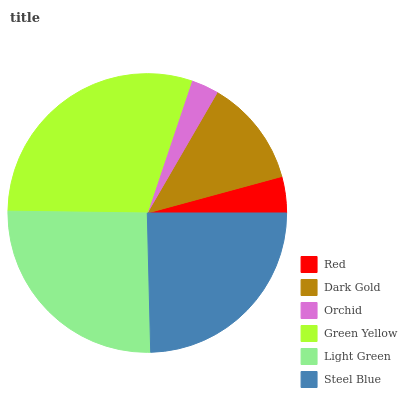Is Orchid the minimum?
Answer yes or no. Yes. Is Green Yellow the maximum?
Answer yes or no. Yes. Is Dark Gold the minimum?
Answer yes or no. No. Is Dark Gold the maximum?
Answer yes or no. No. Is Dark Gold greater than Red?
Answer yes or no. Yes. Is Red less than Dark Gold?
Answer yes or no. Yes. Is Red greater than Dark Gold?
Answer yes or no. No. Is Dark Gold less than Red?
Answer yes or no. No. Is Steel Blue the high median?
Answer yes or no. Yes. Is Dark Gold the low median?
Answer yes or no. Yes. Is Dark Gold the high median?
Answer yes or no. No. Is Light Green the low median?
Answer yes or no. No. 